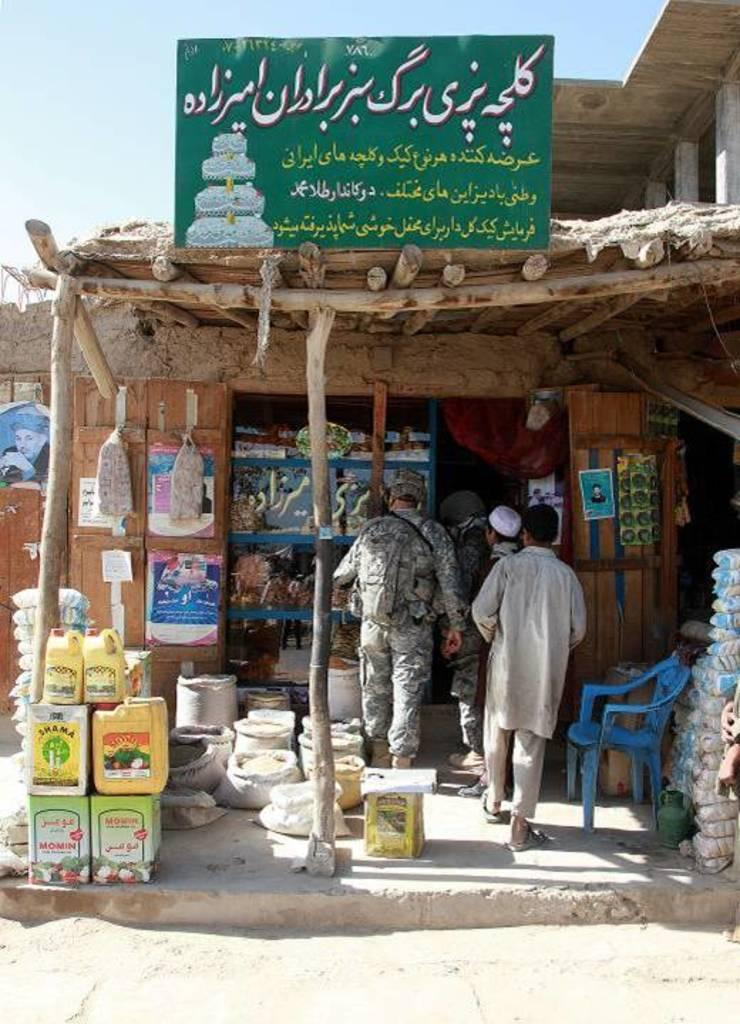What are the people in the image doing? The persons standing on the floor in the image are likely standing or interacting with the hut. What type of structure is depicted in the image? The image depicts a hut. What type of furniture is present in the image? There is a chair in the image. What can be seen in the background of the image? The sky and a board are visible in the background of the image. What type of substance is the snail leaving on the chair in the image? There is no snail present in the image, so there is no substance left on the chair. 